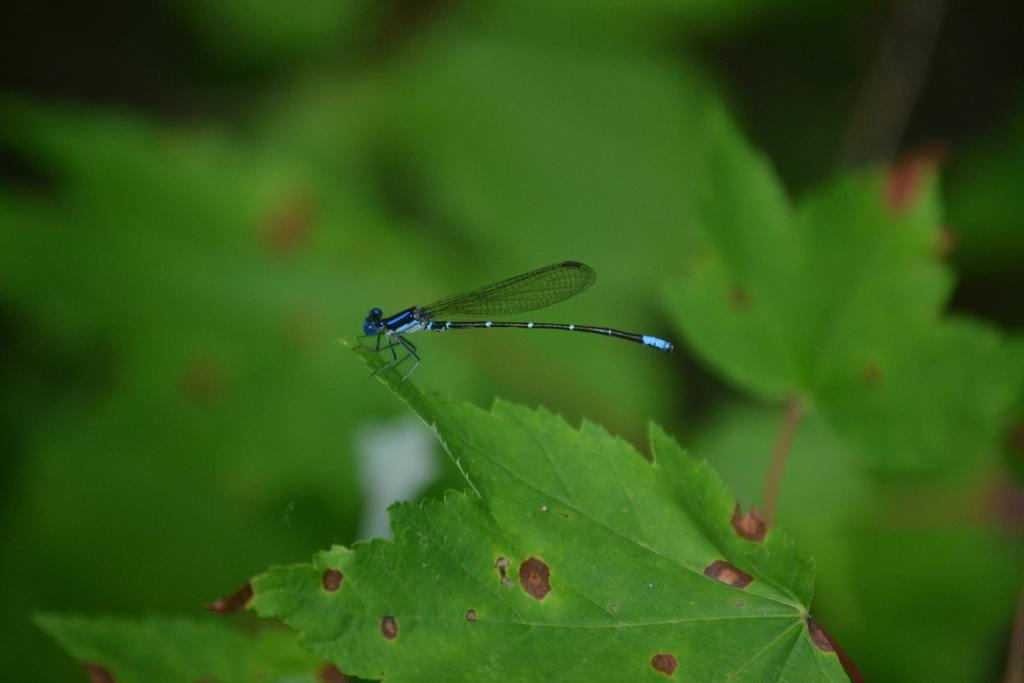What type of creature is in the image? There is an insect in the image. What features does the insect have? The insect has wings, a tail, and legs. Where is the insect located in the image? The insect is standing on a green leaf. What can be observed about the background of the image? The background of the image is blurred. What type of competition is taking place in the image? There is no competition present in the image; it features an insect standing on a green leaf. How does the garden in the image show respect for the insect? There is no garden present in the image, and the concept of respect for the insect cannot be determined from the image. 